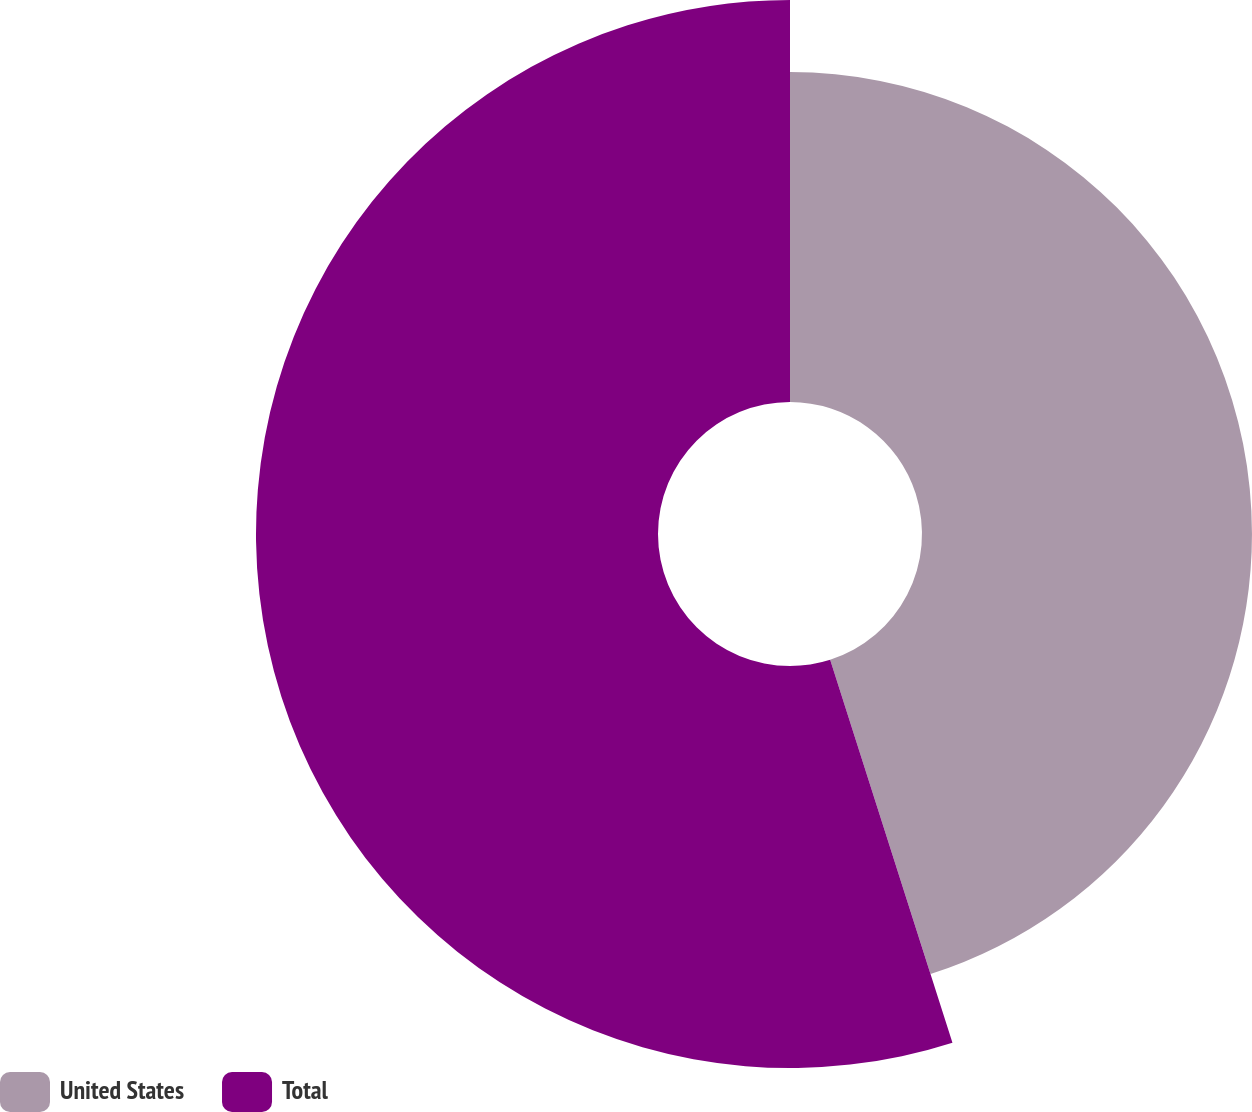Convert chart. <chart><loc_0><loc_0><loc_500><loc_500><pie_chart><fcel>United States<fcel>Total<nl><fcel>45.08%<fcel>54.92%<nl></chart> 